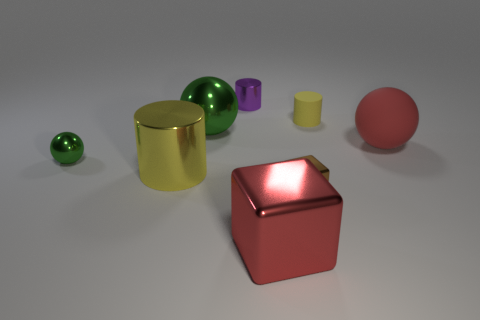Subtract all tiny spheres. How many spheres are left? 2 Subtract all green spheres. How many spheres are left? 1 Add 1 green spheres. How many objects exist? 9 Subtract all blocks. How many objects are left? 6 Subtract 1 spheres. How many spheres are left? 2 Subtract all green balls. Subtract all green cubes. How many balls are left? 1 Subtract all red cylinders. How many green spheres are left? 2 Subtract all yellow shiny objects. Subtract all tiny balls. How many objects are left? 6 Add 6 big red objects. How many big red objects are left? 8 Add 7 small spheres. How many small spheres exist? 8 